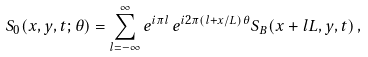<formula> <loc_0><loc_0><loc_500><loc_500>S _ { 0 } ( x , y , t ; \theta ) = \sum _ { l = - \infty } ^ { \infty } e ^ { i \pi l } \, e ^ { i 2 \pi ( l + x / L ) \theta } S _ { B } ( x + l L , y , t ) \, ,</formula> 